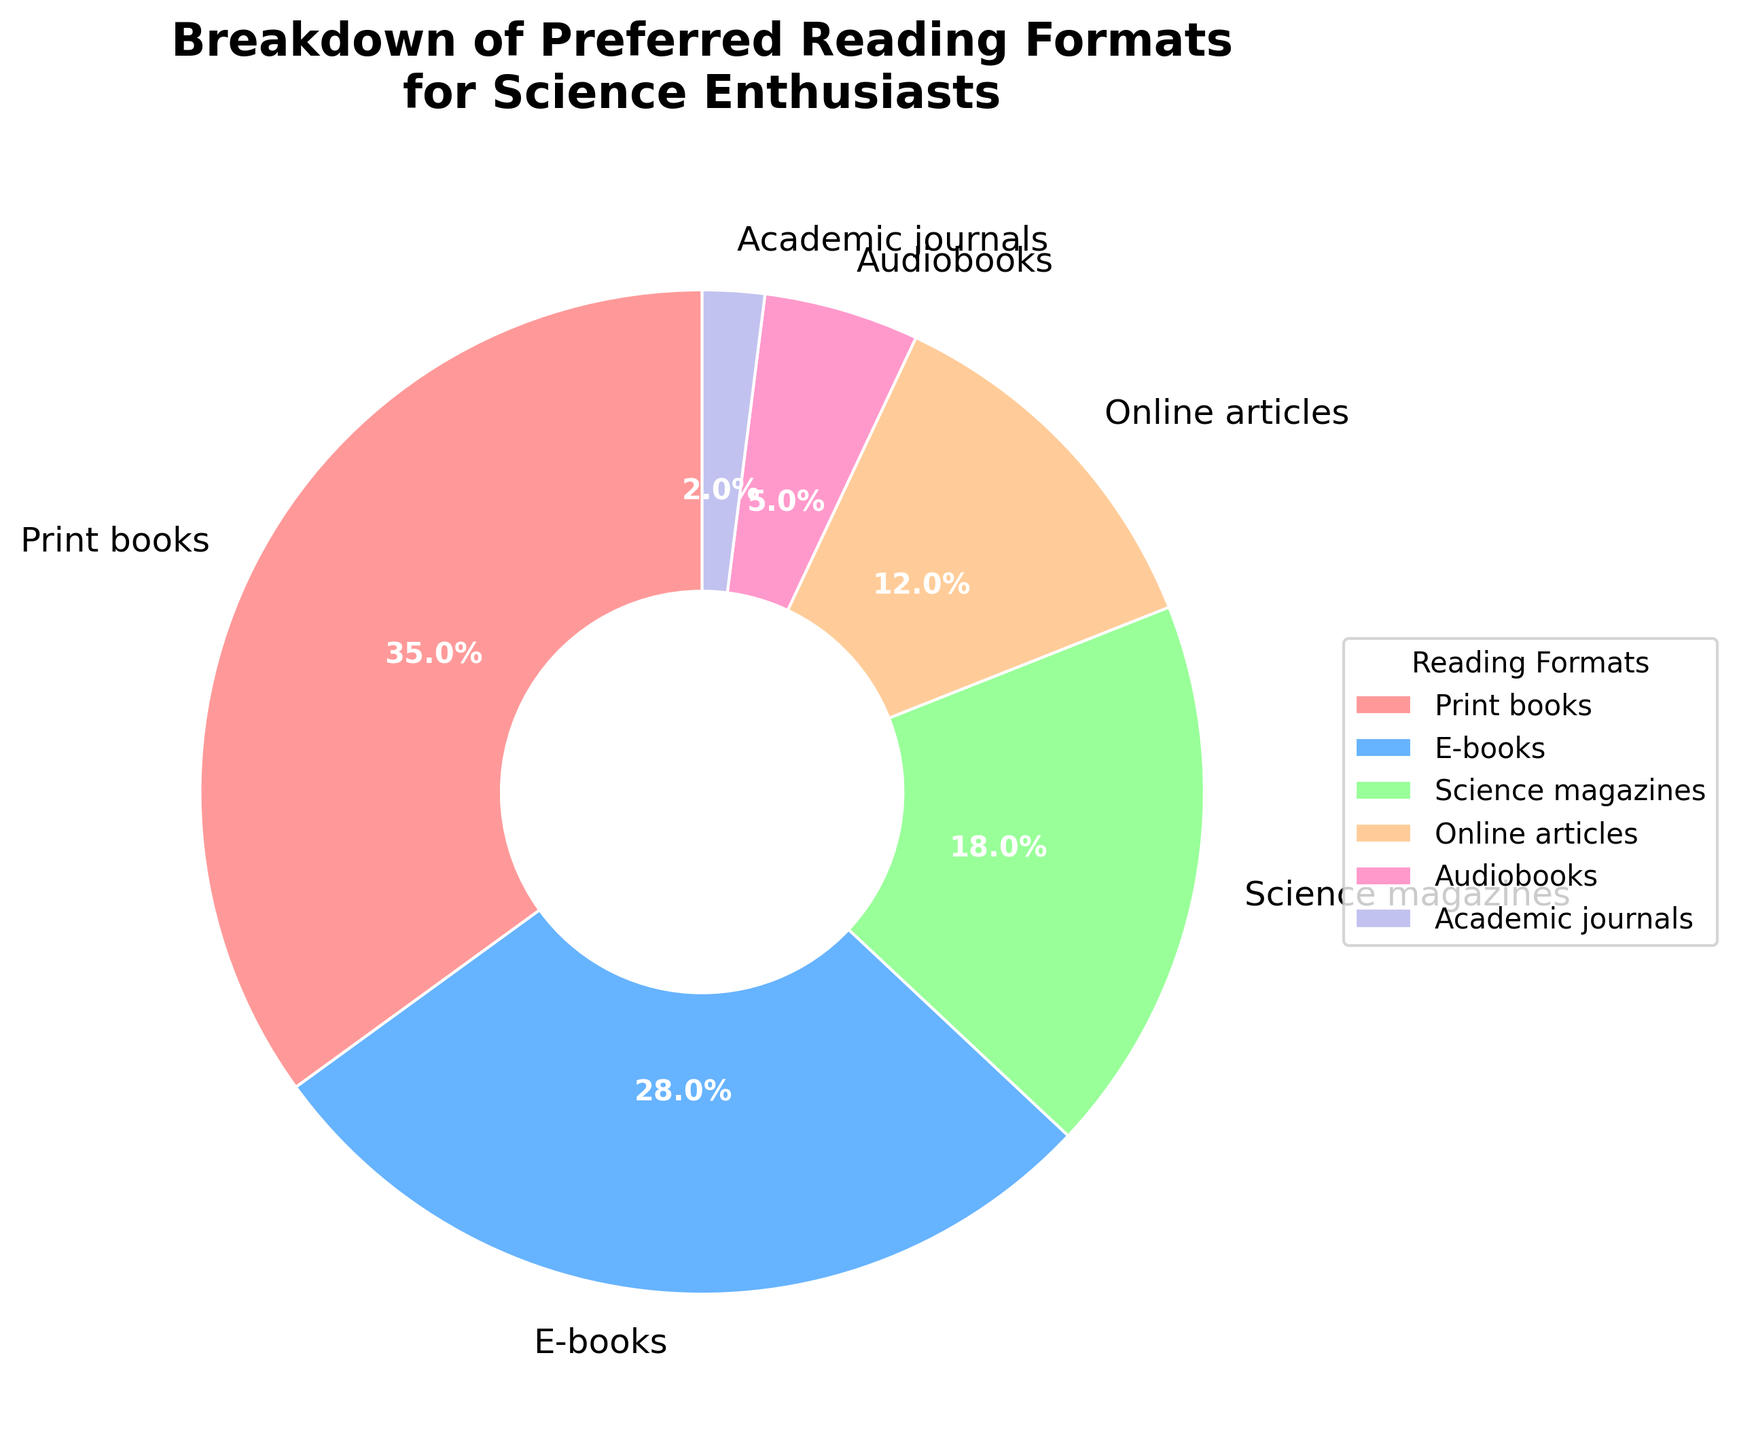Which reading format do science enthusiasts prefer the most? By looking at the pie chart, identify the segment with the largest percentage, which is Print books with 35%.
Answer: Print books How much more popular are print books compared to audiobooks? Print books are at 35% and audiobooks are at 5%, so subtract 5% from 35%.
Answer: 30% What is the total percentage of people who prefer online articles and academic journals? Online articles are 12% and academic journals are 2%, so add these two percentages together.
Answer: 14% Between e-books and science magazines, which has a higher preference and by how much? E-books are 28% and science magazines are 18%, so subtract 18% from 28%.
Answer: E-books by 10% Which two formats have the smallest preference among science enthusiasts, and what is their combined percentage? The two smallest wedges are academic journals (2%) and audiobooks (5%), so add these two percentages together.
Answer: Academic journals and audiobooks, 7% Is the percentage of people preferring e-books higher or lower than those preferring science magazines? Identify that e-books are 28% while science magazines are 18%, then observe that 28% is higher than 18%.
Answer: Higher What is the combined percentage of people who prefer print and e-books? Print books are 35% and e-books are 28%, so add these two percentages together.
Answer: 63% How many times more popular are online articles compared to academic journals? Online articles are 12% and academic journals are 2%, divide 12% by 2%.
Answer: 6 times Which color represents the preference for audiobooks in the pie chart? By observing the pie chart and corresponding legend, the segment representing audiobooks is pink.
Answer: Pink 